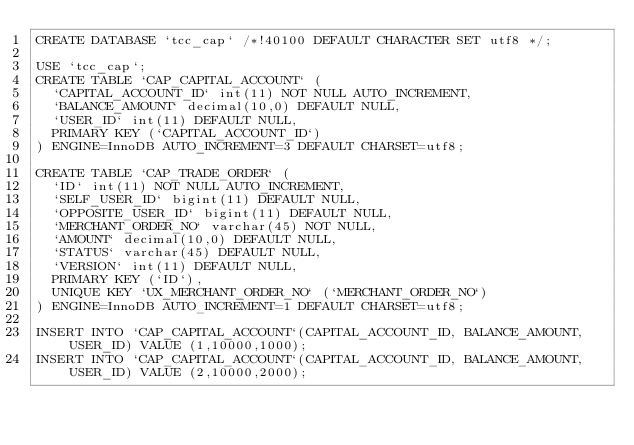Convert code to text. <code><loc_0><loc_0><loc_500><loc_500><_SQL_>CREATE DATABASE `tcc_cap` /*!40100 DEFAULT CHARACTER SET utf8 */;

USE `tcc_cap`;
CREATE TABLE `CAP_CAPITAL_ACCOUNT` (
  `CAPITAL_ACCOUNT_ID` int(11) NOT NULL AUTO_INCREMENT,
  `BALANCE_AMOUNT` decimal(10,0) DEFAULT NULL,
  `USER_ID` int(11) DEFAULT NULL,
  PRIMARY KEY (`CAPITAL_ACCOUNT_ID`)
) ENGINE=InnoDB AUTO_INCREMENT=3 DEFAULT CHARSET=utf8;

CREATE TABLE `CAP_TRADE_ORDER` (
  `ID` int(11) NOT NULL AUTO_INCREMENT,
  `SELF_USER_ID` bigint(11) DEFAULT NULL,
  `OPPOSITE_USER_ID` bigint(11) DEFAULT NULL,
  `MERCHANT_ORDER_NO` varchar(45) NOT NULL,
  `AMOUNT` decimal(10,0) DEFAULT NULL,
  `STATUS` varchar(45) DEFAULT NULL,
  `VERSION` int(11) DEFAULT NULL,
  PRIMARY KEY (`ID`),
  UNIQUE KEY `UX_MERCHANT_ORDER_NO` (`MERCHANT_ORDER_NO`)
) ENGINE=InnoDB AUTO_INCREMENT=1 DEFAULT CHARSET=utf8;

INSERT INTO `CAP_CAPITAL_ACCOUNT`(CAPITAL_ACCOUNT_ID, BALANCE_AMOUNT, USER_ID) VALUE (1,10000,1000);
INSERT INTO `CAP_CAPITAL_ACCOUNT`(CAPITAL_ACCOUNT_ID, BALANCE_AMOUNT, USER_ID) VALUE (2,10000,2000);</code> 